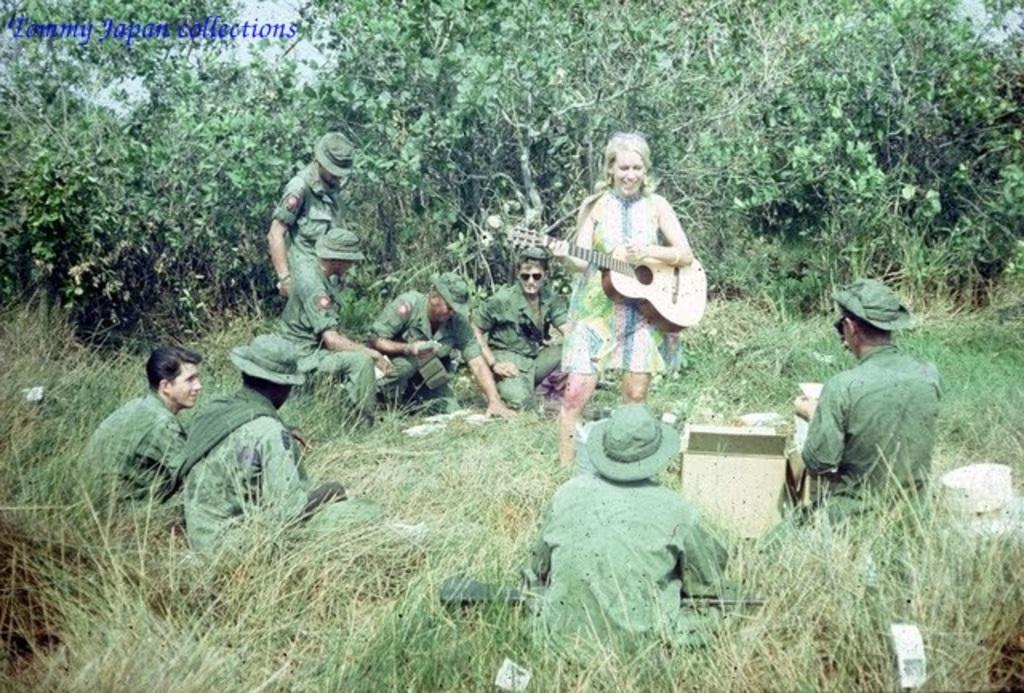What type of vegetation is present in the image? There is grass and trees in the image. What else can be seen in the image besides vegetation? There are people in the image. Can you describe the natural setting in the image? The natural setting includes grass and trees. What type of bubble can be seen floating in the image? There is no bubble present in the image. Can you describe the wren perched on the tree in the image? There is no wren present in the image; only people, grass, and trees are visible. 